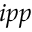<formula> <loc_0><loc_0><loc_500><loc_500>i p p</formula> 